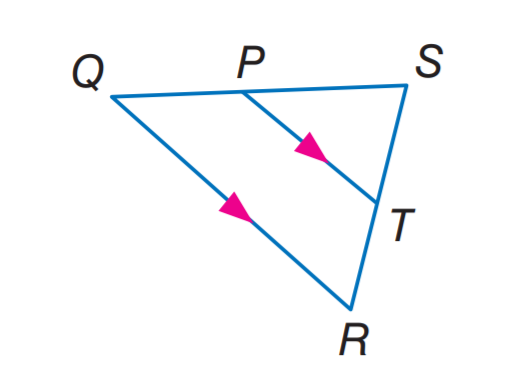Answer the mathemtical geometry problem and directly provide the correct option letter.
Question: If S P = 4, P T = 6, and Q R = 12, find S Q.
Choices: A: 4 B: 6 C: 8 D: 12 C 